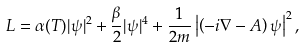Convert formula to latex. <formula><loc_0><loc_0><loc_500><loc_500>L = \alpha ( T ) | \psi | ^ { 2 } + \frac { \beta } 2 | \psi | ^ { 4 } + \frac { 1 } { 2 m } \left | \left ( - i \nabla - A \right ) \psi \right | ^ { 2 } ,</formula> 